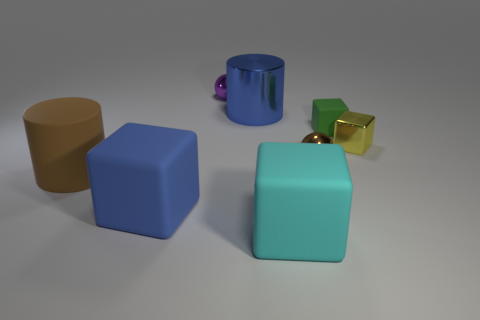There is a purple thing that is the same shape as the brown shiny thing; what size is it?
Offer a terse response. Small. There is a yellow thing; is it the same size as the cylinder in front of the yellow block?
Provide a succinct answer. No. The blue rubber object has what size?
Offer a very short reply. Large. Are there fewer brown metallic objects that are in front of the large cyan rubber thing than small yellow things?
Your answer should be very brief. Yes. Do the blue metallic cylinder and the cyan thing have the same size?
Provide a short and direct response. Yes. What is the color of the large cylinder that is the same material as the green block?
Your answer should be very brief. Brown. Is the number of blue rubber blocks in front of the small purple thing less than the number of small brown spheres right of the yellow shiny thing?
Offer a very short reply. No. How many matte blocks have the same color as the large shiny thing?
Offer a very short reply. 1. There is a object that is the same color as the metallic cylinder; what is it made of?
Keep it short and to the point. Rubber. How many spheres are behind the brown metallic thing and in front of the small green rubber block?
Your answer should be compact. 0. 